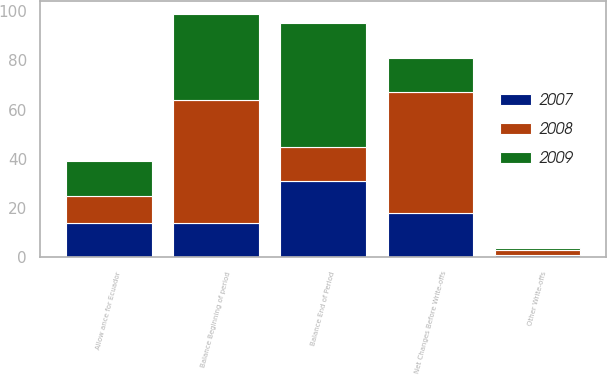Convert chart to OTSL. <chart><loc_0><loc_0><loc_500><loc_500><stacked_bar_chart><ecel><fcel>Balance Beginning of period<fcel>Allow ance for Ecuador<fcel>Net Changes Before Write-offs<fcel>Other Write-offs<fcel>Balance End of Period<nl><fcel>2007<fcel>14<fcel>14<fcel>18<fcel>1<fcel>31<nl><fcel>2008<fcel>50<fcel>11<fcel>49<fcel>2<fcel>14<nl><fcel>2009<fcel>35<fcel>14<fcel>14<fcel>1<fcel>50<nl></chart> 